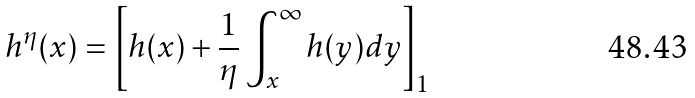Convert formula to latex. <formula><loc_0><loc_0><loc_500><loc_500>h ^ { \eta } ( x ) = \left [ h ( x ) + \frac { 1 } { \eta } \int _ { x } ^ { \infty } h ( y ) d y \right ] _ { 1 }</formula> 